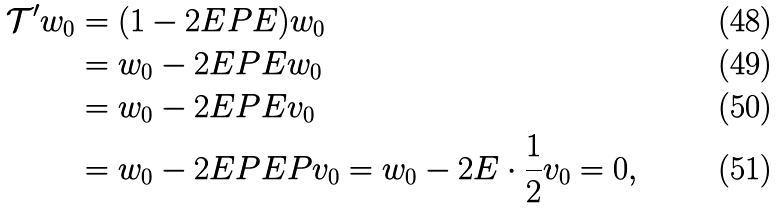Convert formula to latex. <formula><loc_0><loc_0><loc_500><loc_500>\mathcal { T } ^ { \prime } w _ { 0 } & = ( 1 - 2 E P E ) w _ { 0 } \\ & = w _ { 0 } - 2 E P E w _ { 0 } \\ & = w _ { 0 } - 2 E P E v _ { 0 } \\ & = w _ { 0 } - 2 E P E P v _ { 0 } = w _ { 0 } - 2 E \cdot \frac { 1 } { 2 } v _ { 0 } = 0 ,</formula> 